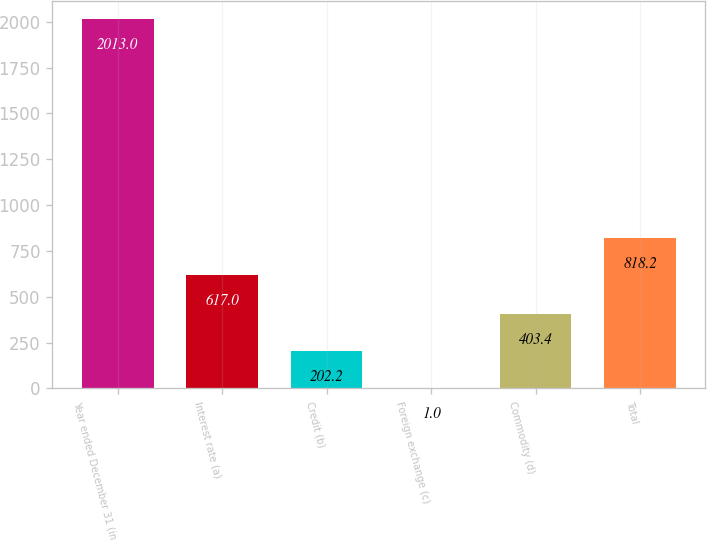<chart> <loc_0><loc_0><loc_500><loc_500><bar_chart><fcel>Year ended December 31 (in<fcel>Interest rate (a)<fcel>Credit (b)<fcel>Foreign exchange (c)<fcel>Commodity (d)<fcel>Total<nl><fcel>2013<fcel>617<fcel>202.2<fcel>1<fcel>403.4<fcel>818.2<nl></chart> 